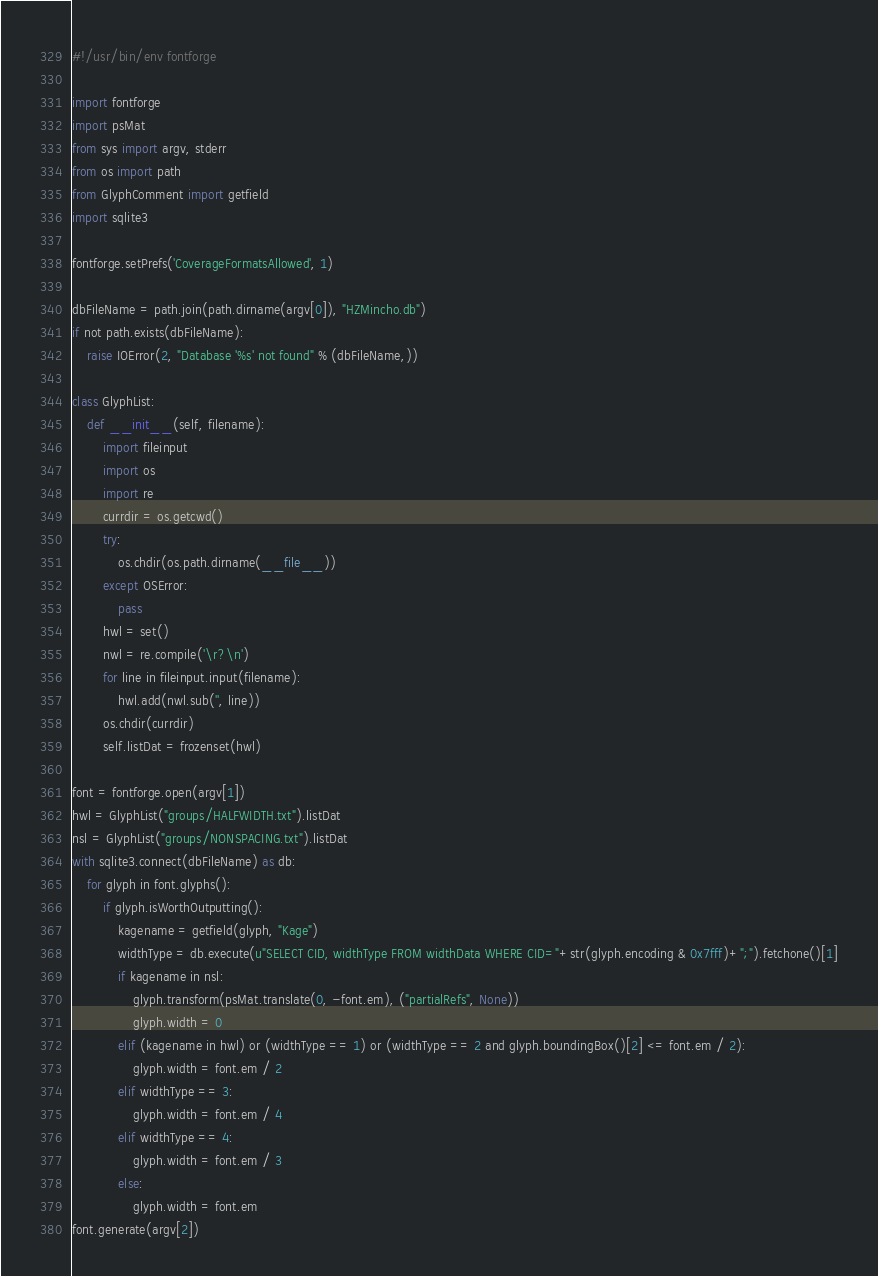Convert code to text. <code><loc_0><loc_0><loc_500><loc_500><_Python_>#!/usr/bin/env fontforge

import fontforge
import psMat
from sys import argv, stderr
from os import path
from GlyphComment import getfield
import sqlite3

fontforge.setPrefs('CoverageFormatsAllowed', 1)

dbFileName = path.join(path.dirname(argv[0]), "HZMincho.db")
if not path.exists(dbFileName):
	raise IOError(2, "Database '%s' not found" % (dbFileName,))

class GlyphList:
	def __init__(self, filename):
		import fileinput
		import os
		import re
		currdir = os.getcwd()
		try:
			os.chdir(os.path.dirname(__file__))
		except OSError:
			pass
		hwl = set()
		nwl = re.compile('\r?\n')
		for line in fileinput.input(filename):
			hwl.add(nwl.sub('', line))
		os.chdir(currdir)
		self.listDat = frozenset(hwl)

font = fontforge.open(argv[1])
hwl = GlyphList("groups/HALFWIDTH.txt").listDat
nsl = GlyphList("groups/NONSPACING.txt").listDat
with sqlite3.connect(dbFileName) as db:
	for glyph in font.glyphs():
		if glyph.isWorthOutputting():
			kagename = getfield(glyph, "Kage")
			widthType = db.execute(u"SELECT CID, widthType FROM widthData WHERE CID="+str(glyph.encoding & 0x7fff)+";").fetchone()[1]
			if kagename in nsl:
				glyph.transform(psMat.translate(0, -font.em), ("partialRefs", None))
				glyph.width = 0
			elif (kagename in hwl) or (widthType == 1) or (widthType == 2 and glyph.boundingBox()[2] <= font.em / 2):
				glyph.width = font.em / 2
			elif widthType == 3:
				glyph.width = font.em / 4
			elif widthType == 4:
				glyph.width = font.em / 3
			else:
				glyph.width = font.em
font.generate(argv[2])
</code> 